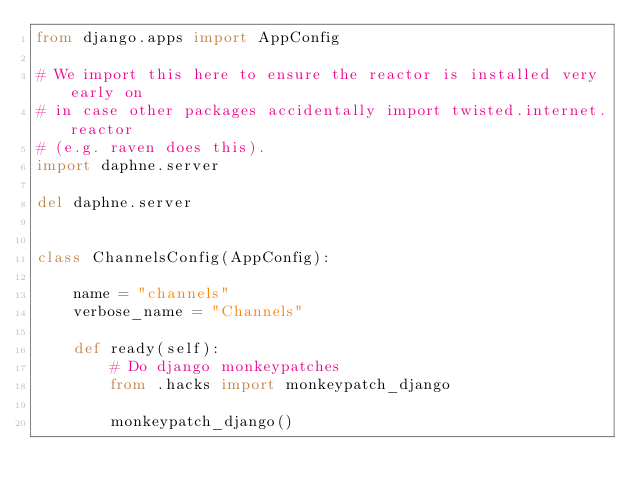<code> <loc_0><loc_0><loc_500><loc_500><_Python_>from django.apps import AppConfig

# We import this here to ensure the reactor is installed very early on
# in case other packages accidentally import twisted.internet.reactor
# (e.g. raven does this).
import daphne.server

del daphne.server


class ChannelsConfig(AppConfig):

    name = "channels"
    verbose_name = "Channels"

    def ready(self):
        # Do django monkeypatches
        from .hacks import monkeypatch_django

        monkeypatch_django()
</code> 